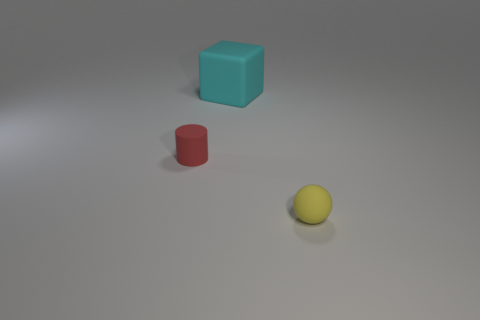What is the color of the other matte thing that is the same size as the red rubber thing?
Offer a very short reply. Yellow. How many large cyan things have the same shape as the red object?
Offer a terse response. 0. How many cylinders are either cyan matte objects or rubber objects?
Give a very brief answer. 1. There is a tiny object to the left of the sphere; does it have the same shape as the tiny object in front of the red thing?
Offer a terse response. No. What is the small ball made of?
Your answer should be very brief. Rubber. How many rubber balls are the same size as the red matte cylinder?
Keep it short and to the point. 1. How many objects are small things that are right of the tiny red matte cylinder or matte objects behind the sphere?
Make the answer very short. 3. Is the material of the thing in front of the red cylinder the same as the tiny thing left of the big cyan matte cube?
Give a very brief answer. Yes. There is a matte thing that is behind the tiny matte thing that is behind the yellow rubber object; what is its shape?
Give a very brief answer. Cube. Is there any other thing that has the same color as the tiny matte ball?
Your response must be concise. No. 